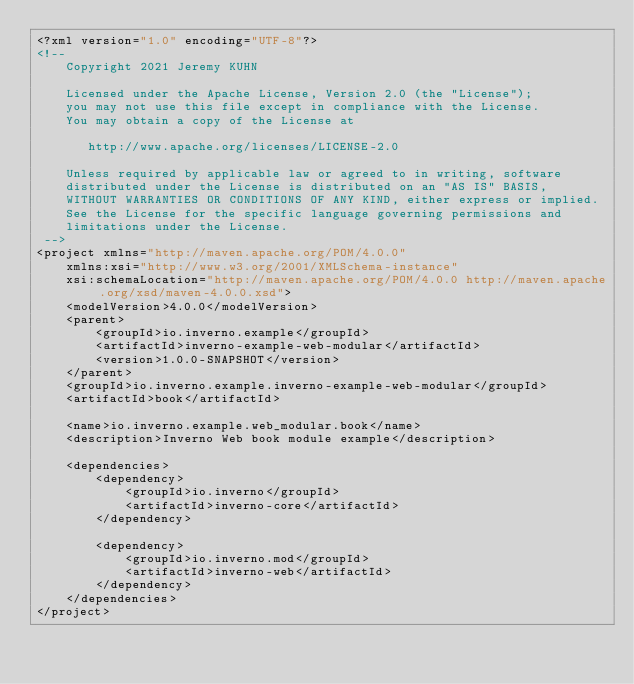Convert code to text. <code><loc_0><loc_0><loc_500><loc_500><_XML_><?xml version="1.0" encoding="UTF-8"?>
<!-- 
	Copyright 2021 Jeremy KUHN
	
	Licensed under the Apache License, Version 2.0 (the "License");
	you may not use this file except in compliance with the License.
	You may obtain a copy of the License at
	
	   http://www.apache.org/licenses/LICENSE-2.0
	
	Unless required by applicable law or agreed to in writing, software
	distributed under the License is distributed on an "AS IS" BASIS,
	WITHOUT WARRANTIES OR CONDITIONS OF ANY KIND, either express or implied.
	See the License for the specific language governing permissions and
	limitations under the License.
 -->
<project xmlns="http://maven.apache.org/POM/4.0.0"
    xmlns:xsi="http://www.w3.org/2001/XMLSchema-instance"
    xsi:schemaLocation="http://maven.apache.org/POM/4.0.0 http://maven.apache.org/xsd/maven-4.0.0.xsd">
    <modelVersion>4.0.0</modelVersion>
    <parent>
		<groupId>io.inverno.example</groupId>
		<artifactId>inverno-example-web-modular</artifactId>
		<version>1.0.0-SNAPSHOT</version>
	</parent>
	<groupId>io.inverno.example.inverno-example-web-modular</groupId>
	<artifactId>book</artifactId>

	<name>io.inverno.example.web_modular.book</name>
	<description>Inverno Web book module example</description>

    <dependencies>
        <dependency>
            <groupId>io.inverno</groupId>
            <artifactId>inverno-core</artifactId>
        </dependency>

        <dependency>
            <groupId>io.inverno.mod</groupId>
            <artifactId>inverno-web</artifactId>
        </dependency>
    </dependencies>
</project>
</code> 